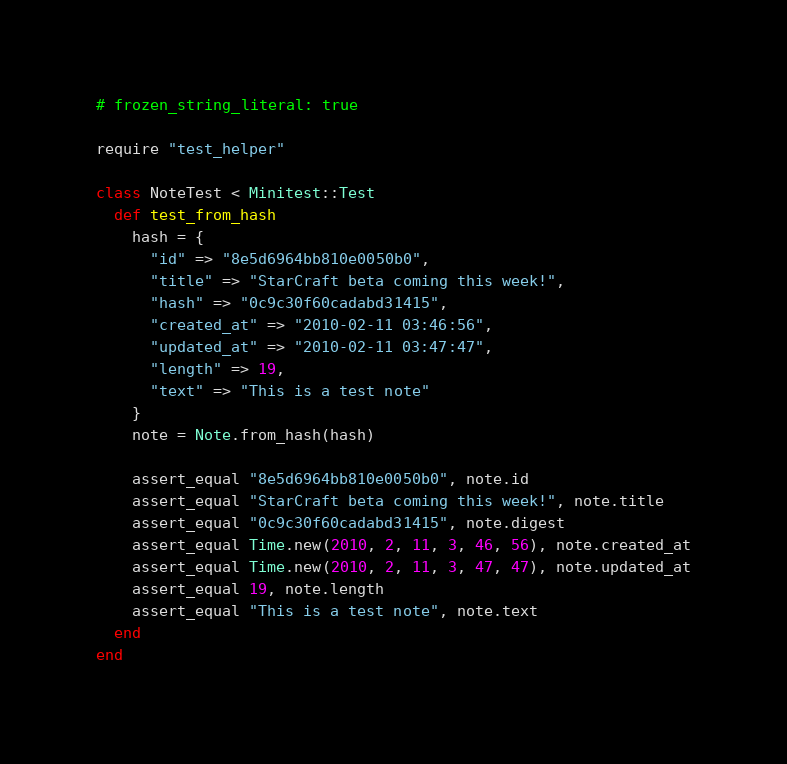<code> <loc_0><loc_0><loc_500><loc_500><_Ruby_># frozen_string_literal: true

require "test_helper"

class NoteTest < Minitest::Test
  def test_from_hash
    hash = {
      "id" => "8e5d6964bb810e0050b0",
      "title" => "StarCraft beta coming this week!",
      "hash" => "0c9c30f60cadabd31415",
      "created_at" => "2010-02-11 03:46:56",
      "updated_at" => "2010-02-11 03:47:47",
      "length" => 19,
      "text" => "This is a test note"
    }
    note = Note.from_hash(hash)

    assert_equal "8e5d6964bb810e0050b0", note.id
    assert_equal "StarCraft beta coming this week!", note.title
    assert_equal "0c9c30f60cadabd31415", note.digest
    assert_equal Time.new(2010, 2, 11, 3, 46, 56), note.created_at
    assert_equal Time.new(2010, 2, 11, 3, 47, 47), note.updated_at
    assert_equal 19, note.length
    assert_equal "This is a test note", note.text
  end
end
</code> 